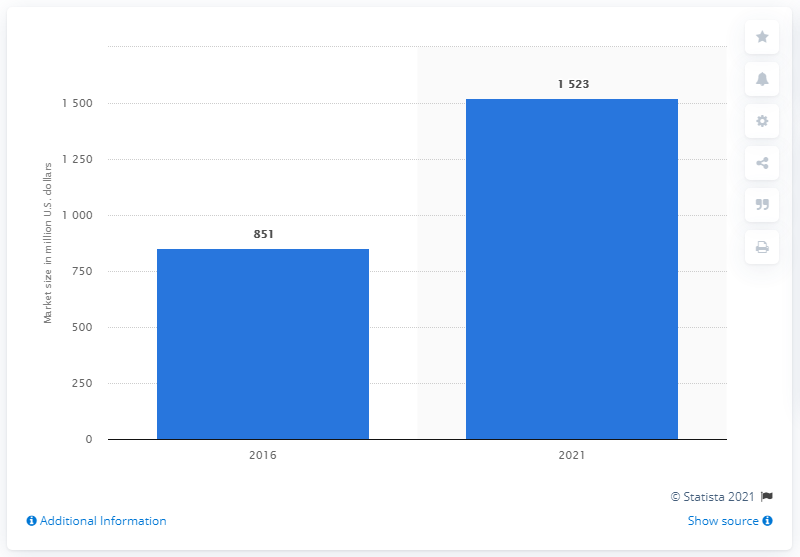List a handful of essential elements in this visual. The forecast for the melatonin supplements market is for the year 2021. 